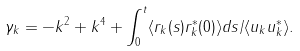Convert formula to latex. <formula><loc_0><loc_0><loc_500><loc_500>\gamma _ { k } = - k ^ { 2 } + k ^ { 4 } + \int _ { 0 } ^ { t } \langle r _ { k } ( s ) r _ { k } ^ { * } ( 0 ) \rangle d s / \langle u _ { k } u _ { k } ^ { * } \rangle .</formula> 